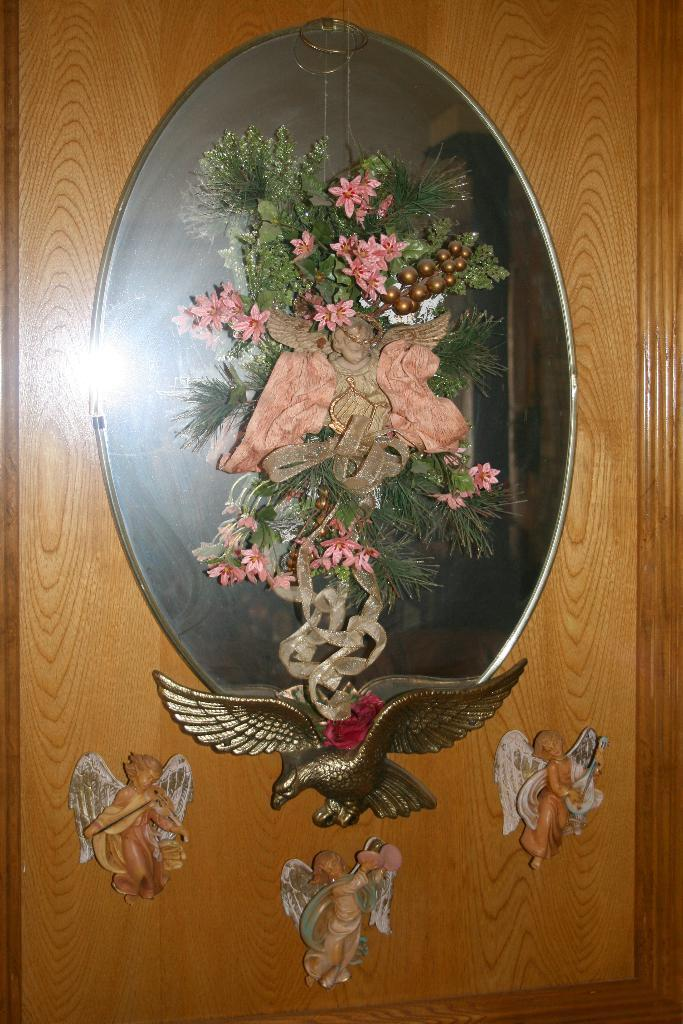What type of surface is visible in the image? There is a wooden surface in the image. What is placed on the wooden surface? There are sculptures on the wooden surface. Can you describe one of the sculptures? There is a sculpture of a bird in the image. What type of decorations can be seen in the image? There are decorations with flowers, leaves, and ribbons in the image. How many holes are visible in the sculpture of the bird? There are no holes visible in the sculpture of the bird, as it is a solid representation of a bird. 